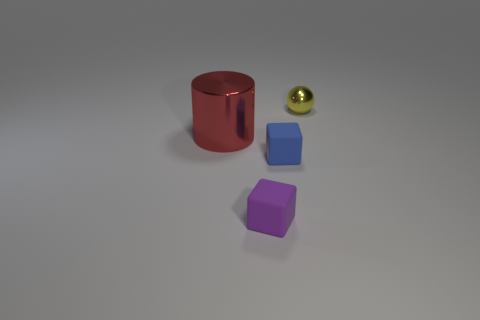Can you describe the materials and textures of the objects shown? Certainly! The objects exhibit a variety of materials and textures. The red object has a reflective, glossy surface, suggesting a material like polished metal or plastic. The dark and light blue cubes have a dull, matte texture, likely rubber or a similar soft material. The purple cube appears slightly reflective and could be made of plastic, while the small golden sphere has a shiny, metallic finish. 